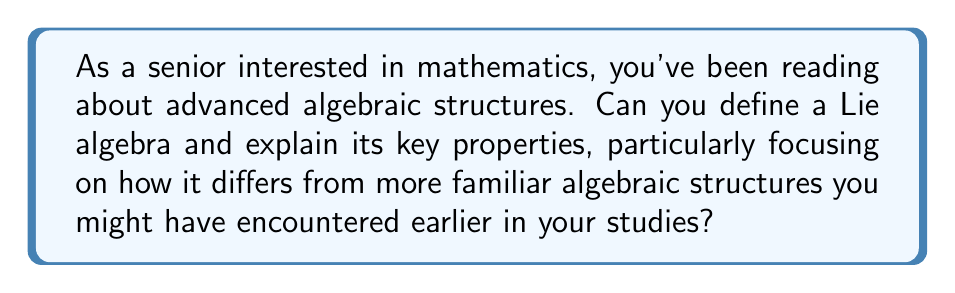Can you answer this question? To understand Lie algebras, let's break down the concept and its properties:

1. Definition:
A Lie algebra is a vector space $L$ over a field $F$ (usually the real or complex numbers), equipped with a binary operation called the Lie bracket $[,]: L \times L \rightarrow L$, which satisfies the following axioms:

a) Bilinearity: For all $x, y, z \in L$ and $a, b \in F$,
   $$[ax + by, z] = a[x,z] + b[y,z]$$
   $$[x, ay + bz] = a[x,y] + b[x,z]$$

b) Antisymmetry: For all $x, y \in L$,
   $$[x,y] = -[y,x]$$

c) Jacobi identity: For all $x, y, z \in L$,
   $$[x,[y,z]] + [y,[z,x]] + [z,[x,y]] = 0$$

2. Key Properties:

a) Non-associativity: Unlike familiar algebraic structures like groups or rings, the Lie bracket operation is generally non-associative. This means that $[[x,y],z] \neq [x,[y,z]]$ in general.

b) Nilpotency of self-bracket: For any element $x$ in a Lie algebra, $[x,x] = 0$. This follows directly from the antisymmetry property.

c) Derivation property: The Lie bracket satisfies the derivation property with respect to itself. For any elements $x, y, z$ in the Lie algebra:
   $$[x,[y,z]] = [[x,y],z] + [y,[x,z]]$$

d) Structure constants: In a finite-dimensional Lie algebra with basis $\{e_1, \ldots, e_n\}$, the Lie bracket can be completely determined by the structure constants $c_{ij}^k$:
   $$[e_i, e_j] = \sum_{k=1}^n c_{ij}^k e_k$$

e) Relationship to Lie groups: Lie algebras are closely related to Lie groups. The Lie algebra of a Lie group can be thought of as the tangent space at the identity element of the group, equipped with the Lie bracket operation.

Lie algebras differ from more familiar algebraic structures in several ways:
1. They lack a multiplicative identity element.
2. The main operation (Lie bracket) is non-associative.
3. They have a more complex set of axioms, particularly the Jacobi identity.

These properties make Lie algebras particularly useful in studying symmetries in physics, differential geometry, and many areas of advanced mathematics.
Answer: A Lie algebra is a vector space equipped with a bilinear, antisymmetric operation called the Lie bracket, which satisfies the Jacobi identity. Its key properties include non-associativity, nilpotency of self-bracket, and the derivation property. Lie algebras differ from more familiar structures by lacking a multiplicative identity, having a non-associative main operation, and possessing a more complex set of axioms. 